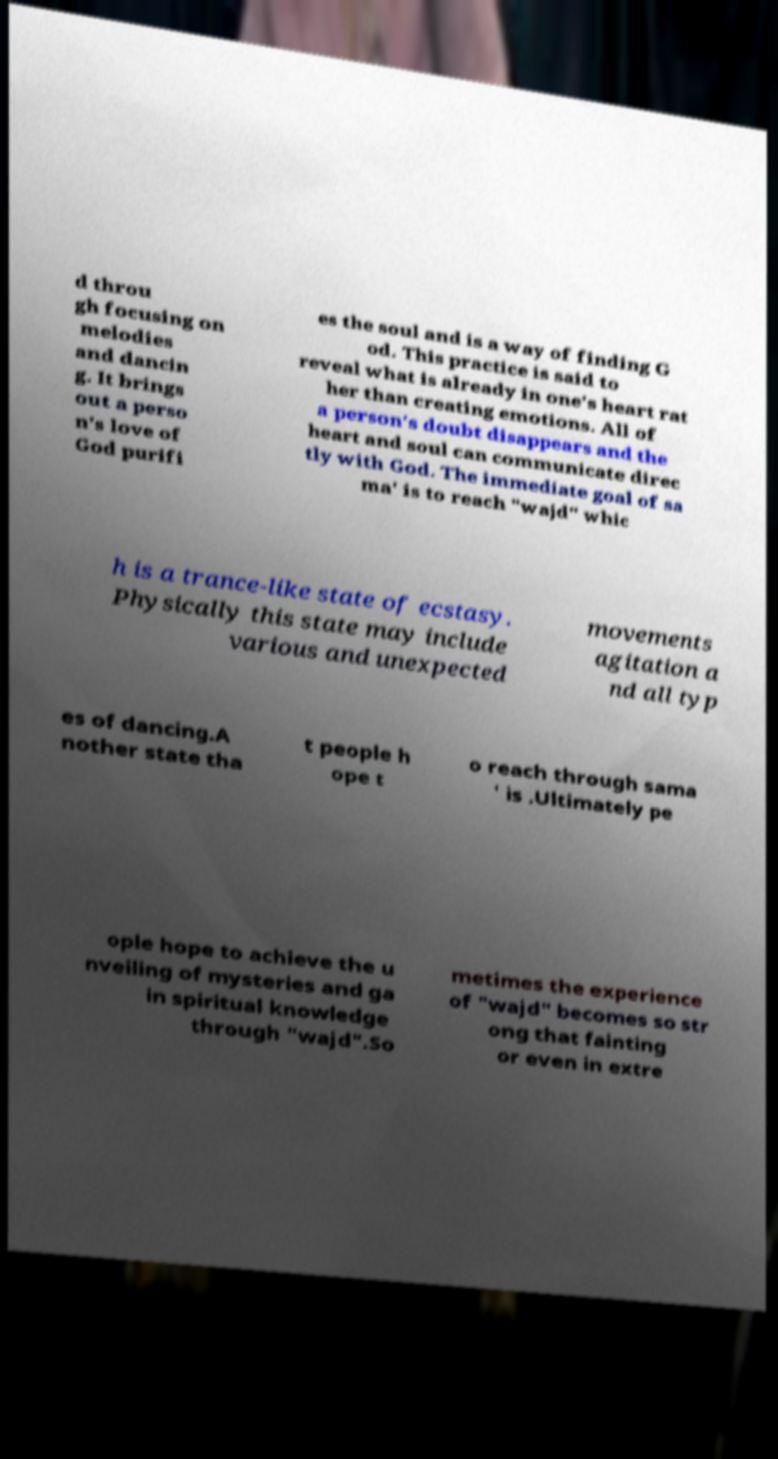What messages or text are displayed in this image? I need them in a readable, typed format. d throu gh focusing on melodies and dancin g. It brings out a perso n's love of God purifi es the soul and is a way of finding G od. This practice is said to reveal what is already in one's heart rat her than creating emotions. All of a person's doubt disappears and the heart and soul can communicate direc tly with God. The immediate goal of sa ma' is to reach "wajd" whic h is a trance-like state of ecstasy. Physically this state may include various and unexpected movements agitation a nd all typ es of dancing.A nother state tha t people h ope t o reach through sama ' is .Ultimately pe ople hope to achieve the u nveiling of mysteries and ga in spiritual knowledge through "wajd".So metimes the experience of "wajd" becomes so str ong that fainting or even in extre 